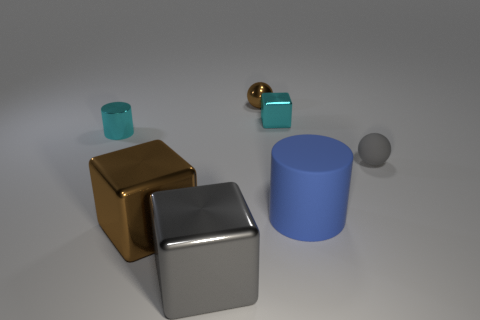What number of other shiny things are the same shape as the large blue object?
Give a very brief answer. 1. Is the shape of the tiny cyan metal thing left of the cyan shiny cube the same as the brown thing that is in front of the small gray matte ball?
Offer a very short reply. No. How many things are tiny cyan cylinders or shiny cubes that are in front of the cyan cylinder?
Provide a succinct answer. 3. What shape is the small thing that is the same color as the small block?
Your answer should be compact. Cylinder. What number of other cubes have the same size as the brown cube?
Provide a succinct answer. 1. What number of yellow objects are either small balls or shiny spheres?
Offer a terse response. 0. The gray thing in front of the tiny matte ball in front of the small cylinder is what shape?
Keep it short and to the point. Cube. There is a gray shiny object that is the same size as the rubber cylinder; what is its shape?
Keep it short and to the point. Cube. Is there a tiny object of the same color as the tiny rubber sphere?
Your answer should be very brief. No. Are there an equal number of small gray rubber objects that are left of the blue rubber cylinder and brown metal cubes that are on the right side of the brown shiny block?
Your answer should be very brief. Yes. 